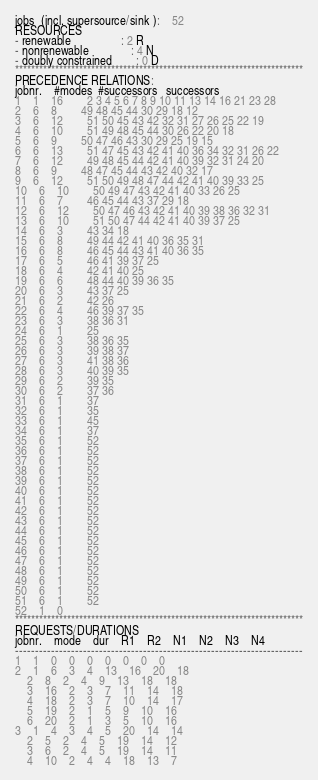<code> <loc_0><loc_0><loc_500><loc_500><_ObjectiveC_>jobs  (incl. supersource/sink ):	52
RESOURCES
- renewable                 : 2 R
- nonrenewable              : 4 N
- doubly constrained        : 0 D
************************************************************************
PRECEDENCE RELATIONS:
jobnr.    #modes  #successors   successors
1	1	16		2 3 4 5 6 7 8 9 10 11 13 14 16 21 23 28 
2	6	8		49 48 45 44 30 29 18 12 
3	6	12		51 50 45 43 42 32 31 27 26 25 22 19 
4	6	10		51 49 48 45 44 30 26 22 20 18 
5	6	9		50 47 46 43 30 29 25 19 15 
6	6	13		51 47 45 43 42 41 40 36 34 32 31 26 22 
7	6	12		49 48 45 44 42 41 40 39 32 31 24 20 
8	6	9		48 47 45 44 43 42 40 32 17 
9	6	12		51 50 49 48 47 44 42 41 40 39 33 25 
10	6	10		50 49 47 43 42 41 40 33 26 25 
11	6	7		46 45 44 43 37 29 18 
12	6	12		50 47 46 43 42 41 40 39 38 36 32 31 
13	6	10		51 50 47 44 42 41 40 39 37 25 
14	6	3		43 34 18 
15	6	8		49 44 42 41 40 36 35 31 
16	6	8		46 45 44 43 41 40 36 35 
17	6	5		46 41 39 37 25 
18	6	4		42 41 40 25 
19	6	6		48 44 40 39 36 35 
20	6	3		43 37 25 
21	6	2		42 26 
22	6	4		46 39 37 35 
23	6	3		38 36 31 
24	6	1		25 
25	6	3		38 36 35 
26	6	3		39 38 37 
27	6	3		41 38 36 
28	6	3		40 39 35 
29	6	2		39 35 
30	6	2		37 36 
31	6	1		37 
32	6	1		35 
33	6	1		45 
34	6	1		37 
35	6	1		52 
36	6	1		52 
37	6	1		52 
38	6	1		52 
39	6	1		52 
40	6	1		52 
41	6	1		52 
42	6	1		52 
43	6	1		52 
44	6	1		52 
45	6	1		52 
46	6	1		52 
47	6	1		52 
48	6	1		52 
49	6	1		52 
50	6	1		52 
51	6	1		52 
52	1	0		
************************************************************************
REQUESTS/DURATIONS
jobnr.	mode	dur	R1	R2	N1	N2	N3	N4	
------------------------------------------------------------------------
1	1	0	0	0	0	0	0	0	
2	1	6	3	4	13	16	20	18	
	2	8	2	4	9	13	18	18	
	3	16	2	3	7	11	14	18	
	4	18	2	3	7	10	14	17	
	5	19	2	1	5	9	10	16	
	6	20	2	1	3	5	10	16	
3	1	4	3	4	5	20	14	14	
	2	5	2	4	5	19	14	12	
	3	6	2	4	5	19	14	11	
	4	10	2	4	4	18	13	7	</code> 